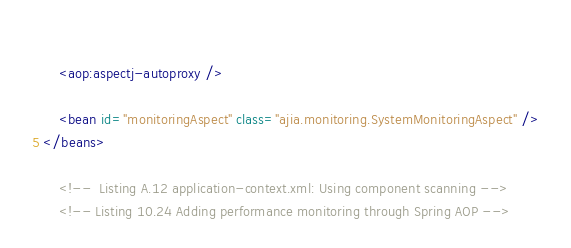Convert code to text. <code><loc_0><loc_0><loc_500><loc_500><_XML_>    
    <aop:aspectj-autoproxy />
    
    <bean id="monitoringAspect" class="ajia.monitoring.SystemMonitoringAspect" />
</beans>

    <!--  Listing A.12 application-context.xml: Using component scanning -->
    <!-- Listing 10.24 Adding performance monitoring through Spring AOP --></code> 